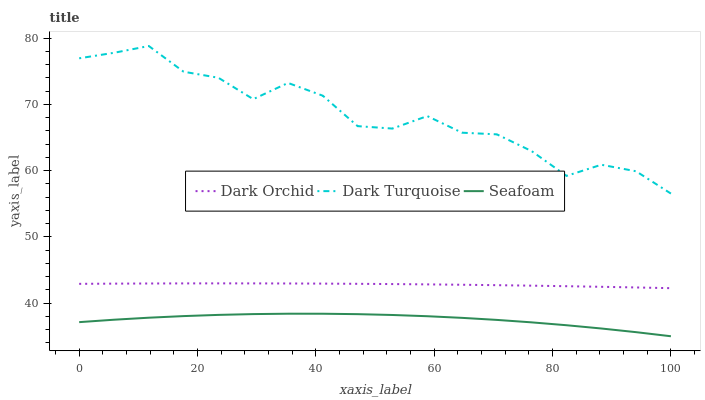Does Dark Orchid have the minimum area under the curve?
Answer yes or no. No. Does Dark Orchid have the maximum area under the curve?
Answer yes or no. No. Is Seafoam the smoothest?
Answer yes or no. No. Is Seafoam the roughest?
Answer yes or no. No. Does Dark Orchid have the lowest value?
Answer yes or no. No. Does Dark Orchid have the highest value?
Answer yes or no. No. Is Dark Orchid less than Dark Turquoise?
Answer yes or no. Yes. Is Dark Turquoise greater than Dark Orchid?
Answer yes or no. Yes. Does Dark Orchid intersect Dark Turquoise?
Answer yes or no. No. 